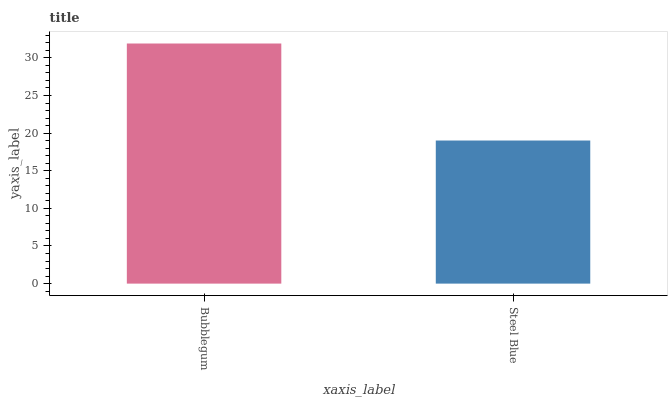Is Steel Blue the minimum?
Answer yes or no. Yes. Is Bubblegum the maximum?
Answer yes or no. Yes. Is Steel Blue the maximum?
Answer yes or no. No. Is Bubblegum greater than Steel Blue?
Answer yes or no. Yes. Is Steel Blue less than Bubblegum?
Answer yes or no. Yes. Is Steel Blue greater than Bubblegum?
Answer yes or no. No. Is Bubblegum less than Steel Blue?
Answer yes or no. No. Is Bubblegum the high median?
Answer yes or no. Yes. Is Steel Blue the low median?
Answer yes or no. Yes. Is Steel Blue the high median?
Answer yes or no. No. Is Bubblegum the low median?
Answer yes or no. No. 